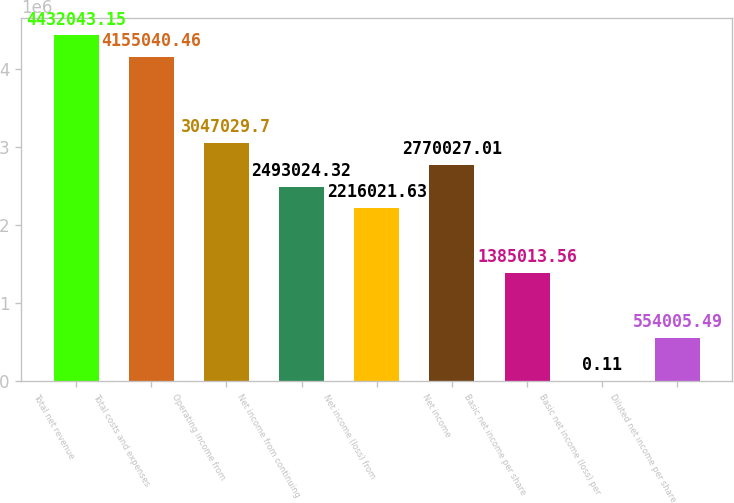Convert chart. <chart><loc_0><loc_0><loc_500><loc_500><bar_chart><fcel>Total net revenue<fcel>Total costs and expenses<fcel>Operating income from<fcel>Net income from continuing<fcel>Net income (loss) from<fcel>Net income<fcel>Basic net income per share<fcel>Basic net income (loss) per<fcel>Diluted net income per share<nl><fcel>4.43204e+06<fcel>4.15504e+06<fcel>3.04703e+06<fcel>2.49302e+06<fcel>2.21602e+06<fcel>2.77003e+06<fcel>1.38501e+06<fcel>0.11<fcel>554005<nl></chart> 